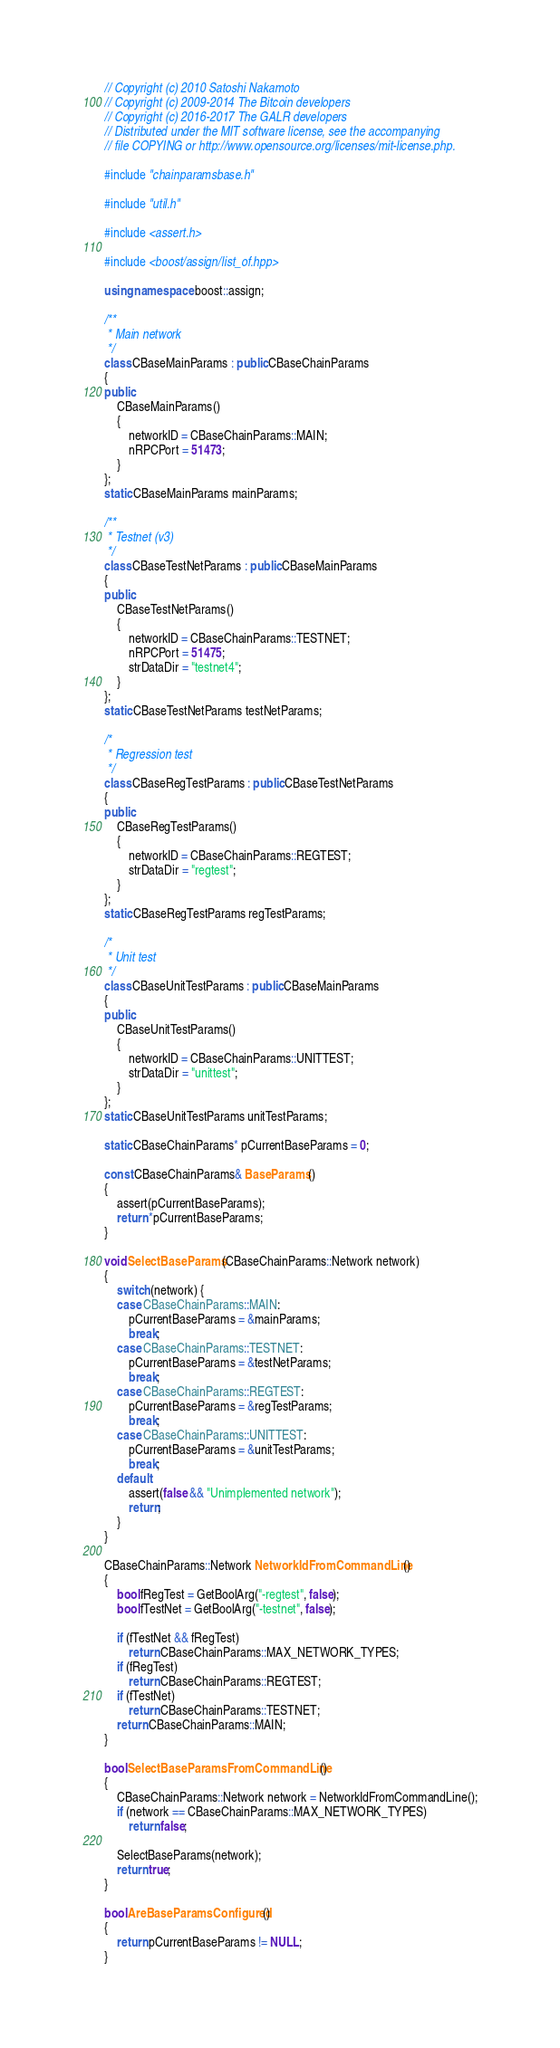Convert code to text. <code><loc_0><loc_0><loc_500><loc_500><_C++_>// Copyright (c) 2010 Satoshi Nakamoto
// Copyright (c) 2009-2014 The Bitcoin developers
// Copyright (c) 2016-2017 The GALR developers
// Distributed under the MIT software license, see the accompanying
// file COPYING or http://www.opensource.org/licenses/mit-license.php.

#include "chainparamsbase.h"

#include "util.h"

#include <assert.h>

#include <boost/assign/list_of.hpp>

using namespace boost::assign;

/**
 * Main network
 */
class CBaseMainParams : public CBaseChainParams
{
public:
    CBaseMainParams()
    {
        networkID = CBaseChainParams::MAIN;
        nRPCPort = 51473;
    }
};
static CBaseMainParams mainParams;

/**
 * Testnet (v3)
 */
class CBaseTestNetParams : public CBaseMainParams
{
public:
    CBaseTestNetParams()
    {
        networkID = CBaseChainParams::TESTNET;
        nRPCPort = 51475;
        strDataDir = "testnet4";
    }
};
static CBaseTestNetParams testNetParams;

/*
 * Regression test
 */
class CBaseRegTestParams : public CBaseTestNetParams
{
public:
    CBaseRegTestParams()
    {
        networkID = CBaseChainParams::REGTEST;
        strDataDir = "regtest";
    }
};
static CBaseRegTestParams regTestParams;

/*
 * Unit test
 */
class CBaseUnitTestParams : public CBaseMainParams
{
public:
    CBaseUnitTestParams()
    {
        networkID = CBaseChainParams::UNITTEST;
        strDataDir = "unittest";
    }
};
static CBaseUnitTestParams unitTestParams;

static CBaseChainParams* pCurrentBaseParams = 0;

const CBaseChainParams& BaseParams()
{
    assert(pCurrentBaseParams);
    return *pCurrentBaseParams;
}

void SelectBaseParams(CBaseChainParams::Network network)
{
    switch (network) {
    case CBaseChainParams::MAIN:
        pCurrentBaseParams = &mainParams;
        break;
    case CBaseChainParams::TESTNET:
        pCurrentBaseParams = &testNetParams;
        break;
    case CBaseChainParams::REGTEST:
        pCurrentBaseParams = &regTestParams;
        break;
    case CBaseChainParams::UNITTEST:
        pCurrentBaseParams = &unitTestParams;
        break;
    default:
        assert(false && "Unimplemented network");
        return;
    }
}

CBaseChainParams::Network NetworkIdFromCommandLine()
{
    bool fRegTest = GetBoolArg("-regtest", false);
    bool fTestNet = GetBoolArg("-testnet", false);

    if (fTestNet && fRegTest)
        return CBaseChainParams::MAX_NETWORK_TYPES;
    if (fRegTest)
        return CBaseChainParams::REGTEST;
    if (fTestNet)
        return CBaseChainParams::TESTNET;
    return CBaseChainParams::MAIN;
}

bool SelectBaseParamsFromCommandLine()
{
    CBaseChainParams::Network network = NetworkIdFromCommandLine();
    if (network == CBaseChainParams::MAX_NETWORK_TYPES)
        return false;

    SelectBaseParams(network);
    return true;
}

bool AreBaseParamsConfigured()
{
    return pCurrentBaseParams != NULL;
}
</code> 